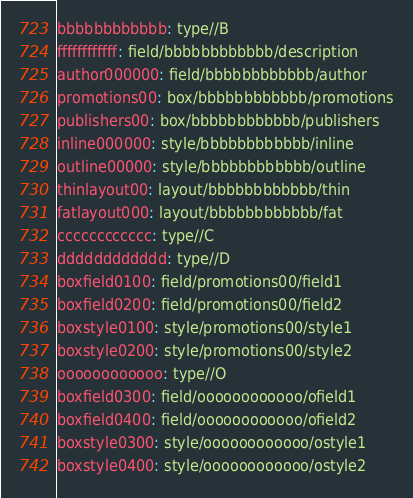Convert code to text. <code><loc_0><loc_0><loc_500><loc_500><_YAML_>bbbbbbbbbbbb: type//B
ffffffffffff: field/bbbbbbbbbbbb/description
author000000: field/bbbbbbbbbbbb/author
promotions00: box/bbbbbbbbbbbb/promotions
publishers00: box/bbbbbbbbbbbb/publishers
inline000000: style/bbbbbbbbbbbb/inline
outline00000: style/bbbbbbbbbbbb/outline
thinlayout00: layout/bbbbbbbbbbbb/thin
fatlayout000: layout/bbbbbbbbbbbb/fat
cccccccccccc: type//C
dddddddddddd: type//D
boxfield0100: field/promotions00/field1
boxfield0200: field/promotions00/field2
boxstyle0100: style/promotions00/style1
boxstyle0200: style/promotions00/style2
oooooooooooo: type//O
boxfield0300: field/oooooooooooo/ofield1
boxfield0400: field/oooooooooooo/ofield2
boxstyle0300: style/oooooooooooo/ostyle1
boxstyle0400: style/oooooooooooo/ostyle2

</code> 